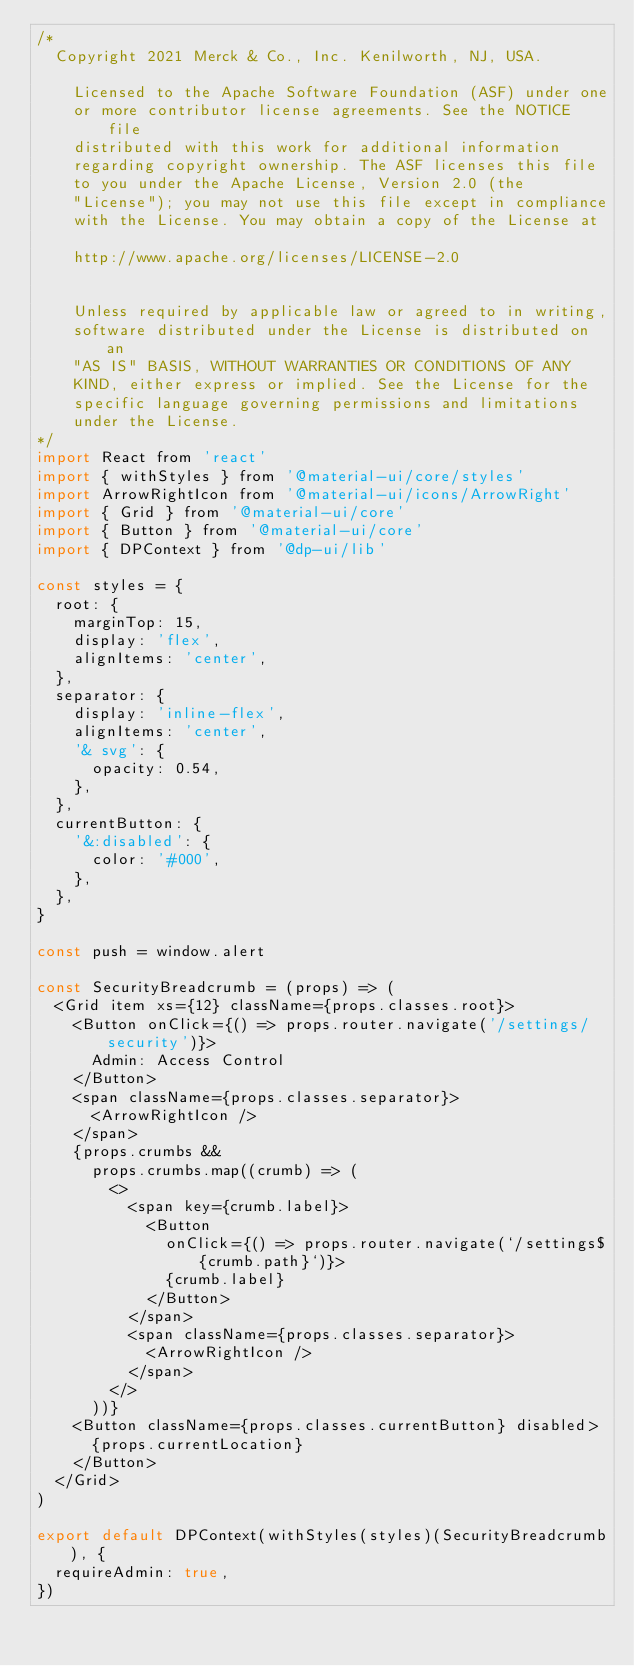<code> <loc_0><loc_0><loc_500><loc_500><_JavaScript_>/*
  Copyright 2021 Merck & Co., Inc. Kenilworth, NJ, USA.
 
 	Licensed to the Apache Software Foundation (ASF) under one
 	or more contributor license agreements. See the NOTICE file
 	distributed with this work for additional information
 	regarding copyright ownership. The ASF licenses this file
 	to you under the Apache License, Version 2.0 (the
 	"License"); you may not use this file except in compliance
 	with the License. You may obtain a copy of the License at
 
 	http://www.apache.org/licenses/LICENSE-2.0
 
 
 	Unless required by applicable law or agreed to in writing,
 	software distributed under the License is distributed on an
 	"AS IS" BASIS, WITHOUT WARRANTIES OR CONDITIONS OF ANY
 	KIND, either express or implied. See the License for the
 	specific language governing permissions and limitations
 	under the License.
*/
import React from 'react'
import { withStyles } from '@material-ui/core/styles'
import ArrowRightIcon from '@material-ui/icons/ArrowRight'
import { Grid } from '@material-ui/core'
import { Button } from '@material-ui/core'
import { DPContext } from '@dp-ui/lib'

const styles = {
  root: {
    marginTop: 15,
    display: 'flex',
    alignItems: 'center',
  },
  separator: {
    display: 'inline-flex',
    alignItems: 'center',
    '& svg': {
      opacity: 0.54,
    },
  },
  currentButton: {
    '&:disabled': {
      color: '#000',
    },
  },
}

const push = window.alert

const SecurityBreadcrumb = (props) => (
  <Grid item xs={12} className={props.classes.root}>
    <Button onClick={() => props.router.navigate('/settings/security')}>
      Admin: Access Control
    </Button>
    <span className={props.classes.separator}>
      <ArrowRightIcon />
    </span>
    {props.crumbs &&
      props.crumbs.map((crumb) => (
        <>
          <span key={crumb.label}>
            <Button
              onClick={() => props.router.navigate(`/settings${crumb.path}`)}>
              {crumb.label}
            </Button>
          </span>
          <span className={props.classes.separator}>
            <ArrowRightIcon />
          </span>
        </>
      ))}
    <Button className={props.classes.currentButton} disabled>
      {props.currentLocation}
    </Button>
  </Grid>
)

export default DPContext(withStyles(styles)(SecurityBreadcrumb), {
  requireAdmin: true,
})
</code> 